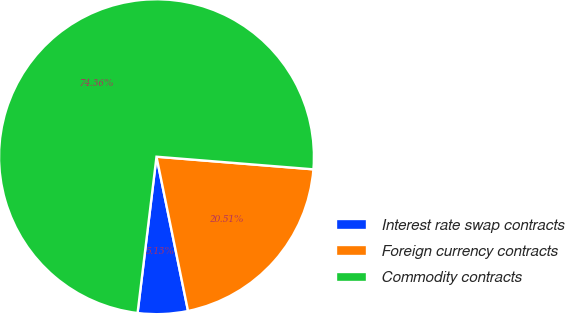Convert chart to OTSL. <chart><loc_0><loc_0><loc_500><loc_500><pie_chart><fcel>Interest rate swap contracts<fcel>Foreign currency contracts<fcel>Commodity contracts<nl><fcel>5.13%<fcel>20.51%<fcel>74.36%<nl></chart> 